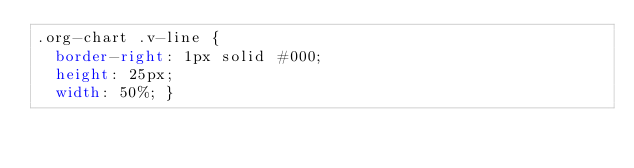<code> <loc_0><loc_0><loc_500><loc_500><_CSS_>.org-chart .v-line {
  border-right: 1px solid #000;
  height: 25px;
  width: 50%; }
</code> 